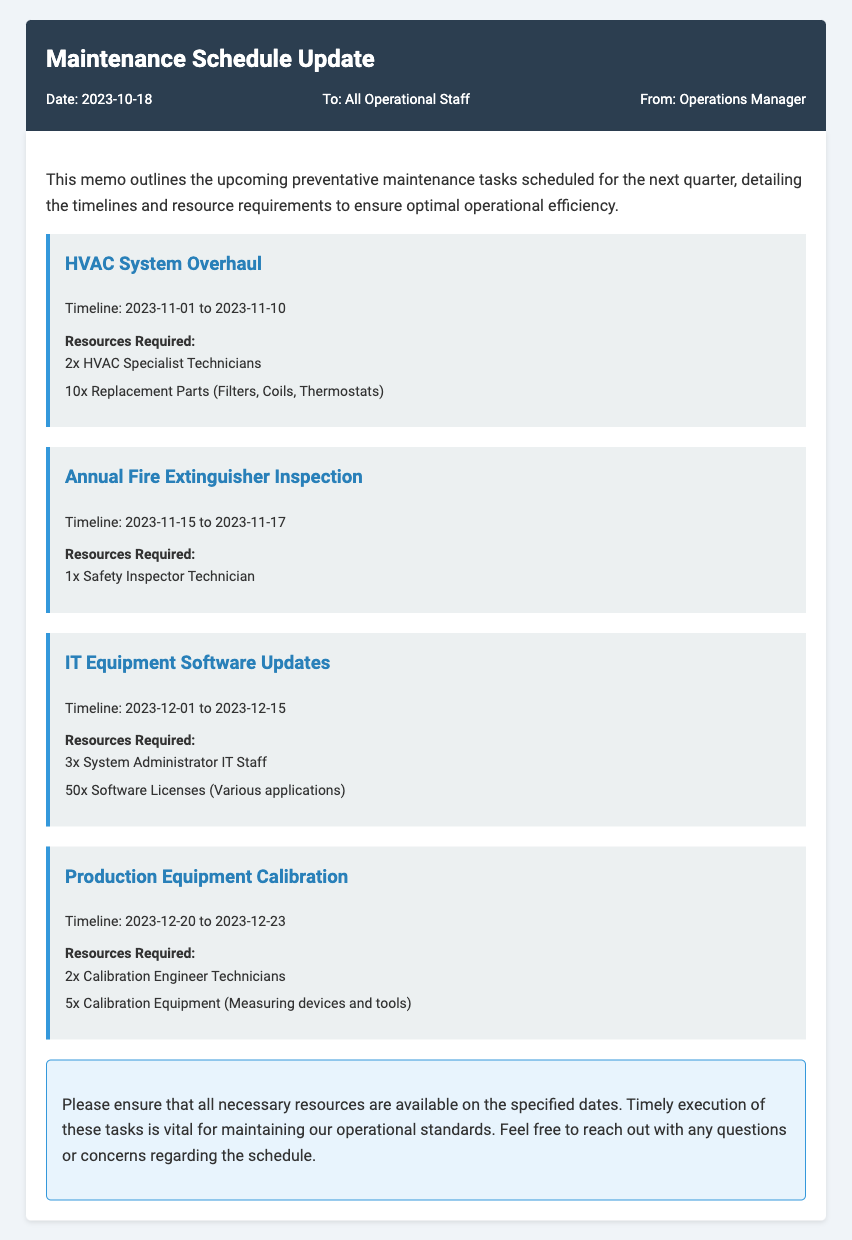What is the date of the memo? The date of the memo is indicated in the document's meta-info section.
Answer: 2023-10-18 What are the resource requirements for the HVAC System Overhaul? The resource requirements for this task are listed under the respective section in the document.
Answer: 2x HVAC Specialist Technicians, 10x Replacement Parts (Filters, Coils, Thermostats) When is the Annual Fire Extinguisher Inspection scheduled? The timeline for this task is specified in its section in the memo.
Answer: 2023-11-15 to 2023-11-17 How many System Administrator IT Staff are needed for IT Equipment Software Updates? This number is specified in the resource requirements for the task in the memo.
Answer: 3x System Administrator IT Staff What is the last maintenance task listed in the document? The document presents tasks in a specific order, and the last one is detailed at the end.
Answer: Production Equipment Calibration What is the duration of the HVAC System Overhaul? This can be determined by looking at the timeline provided for the specific task.
Answer: 10 days Who is the author of this memo? The author is listed in the meta-info section of the document.
Answer: Operations Manager What is the timeline for Production Equipment Calibration? The timeline is explicitly mentioned in the section for that task.
Answer: 2023-12-20 to 2023-12-23 How many replacement parts are needed for the HVAC System Overhaul? The document lists the specific quantity of replacement parts required for this task.
Answer: 10x Replacement Parts (Filters, Coils, Thermostats) 